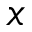Convert formula to latex. <formula><loc_0><loc_0><loc_500><loc_500>x</formula> 